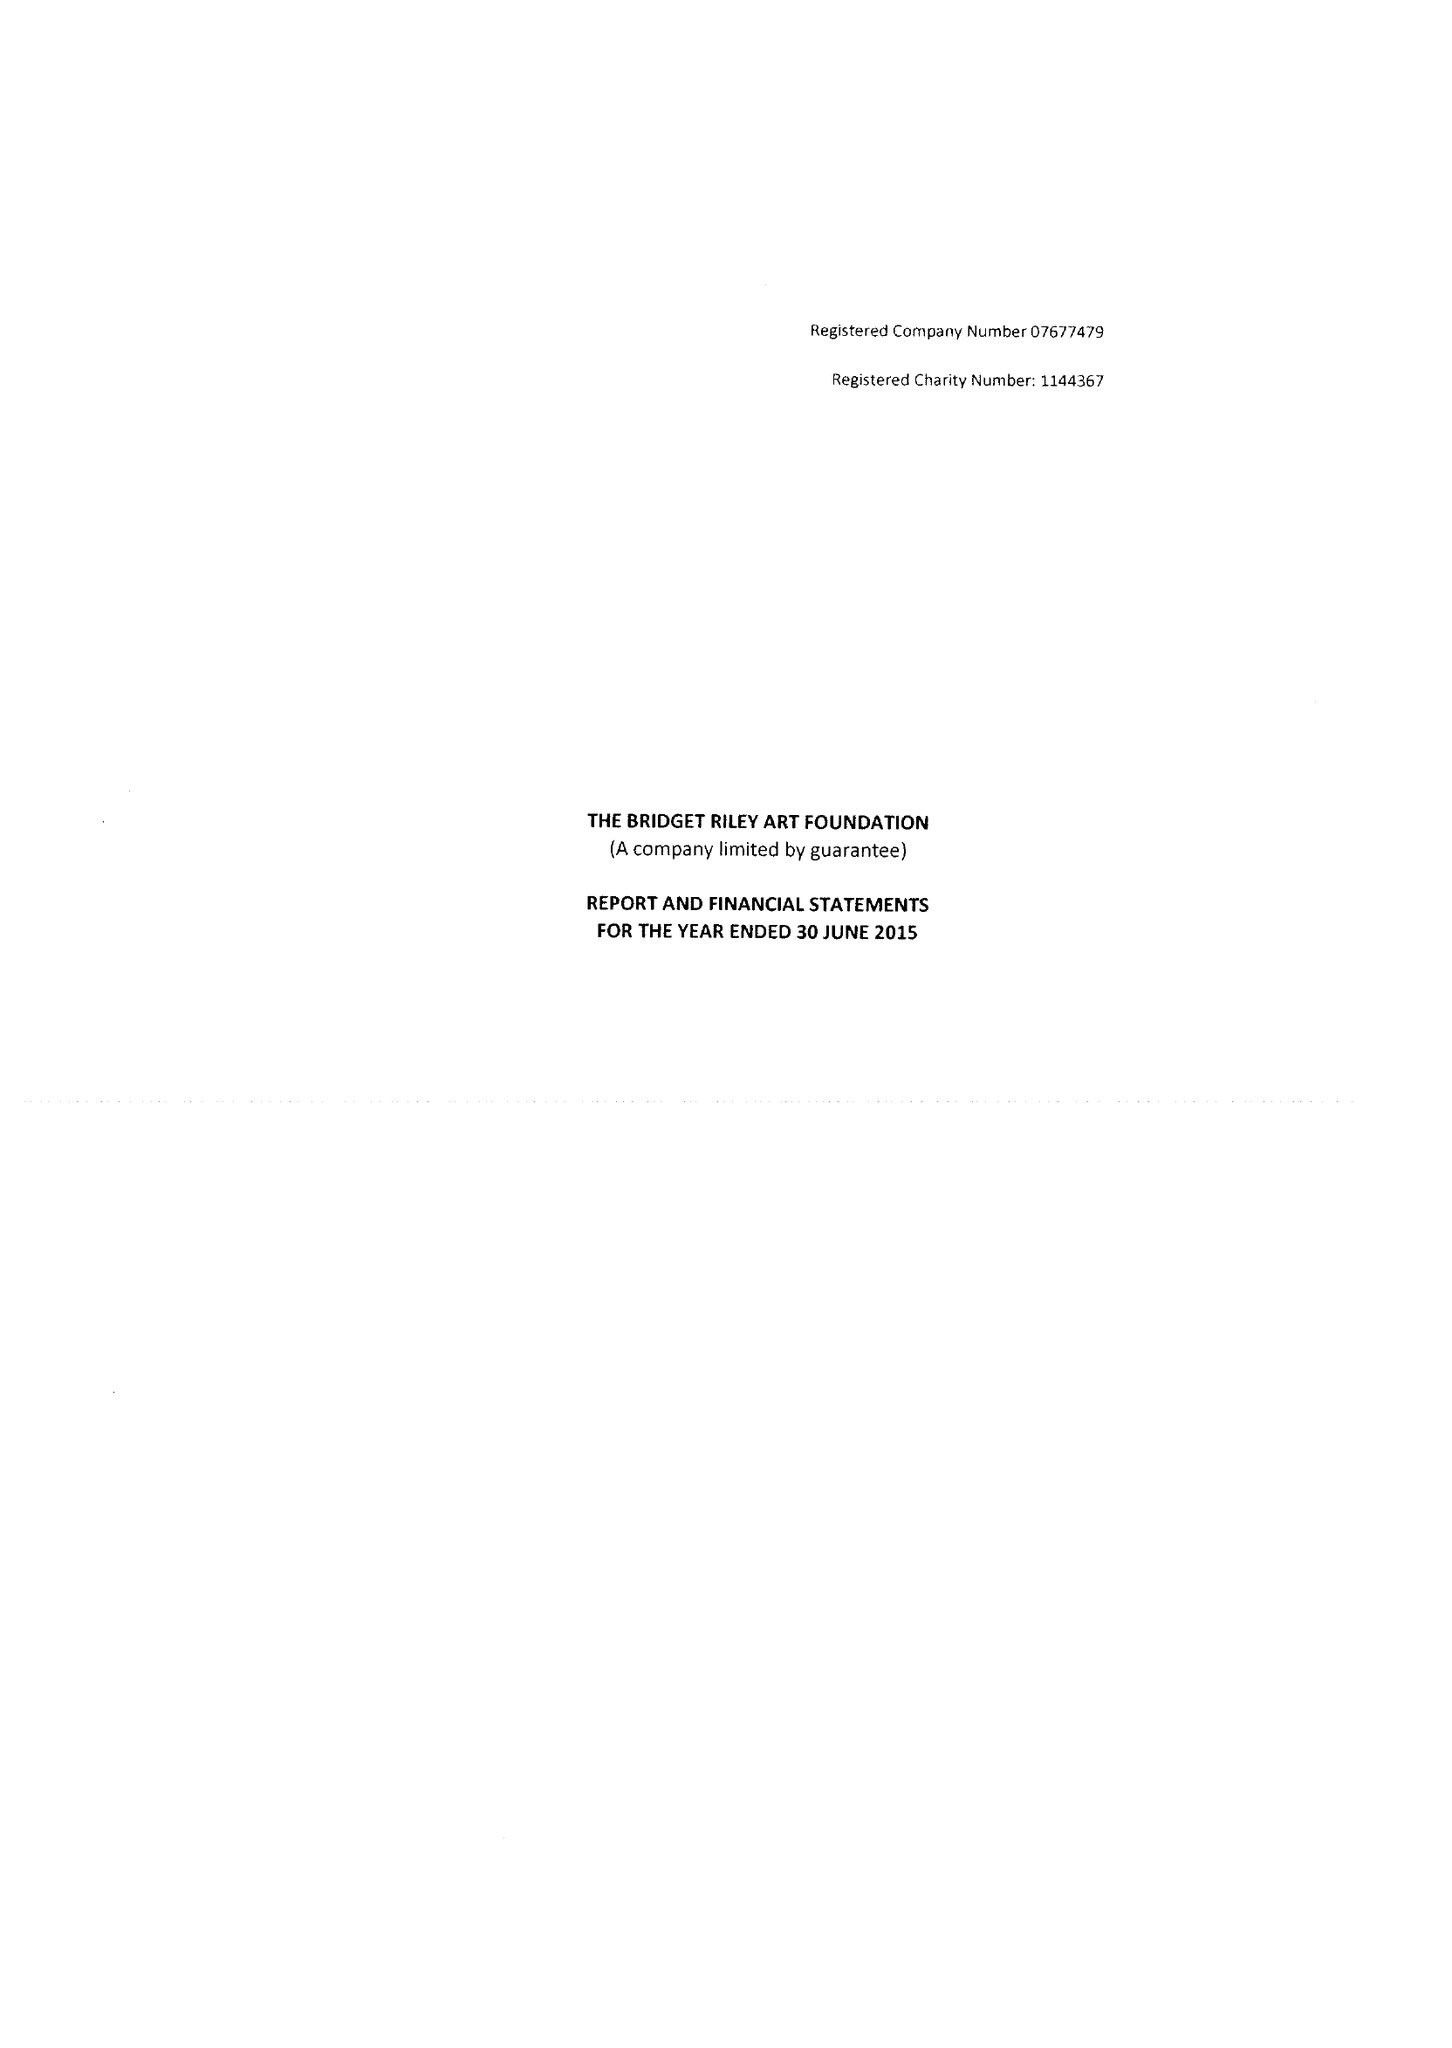What is the value for the address__post_town?
Answer the question using a single word or phrase. LONDON 